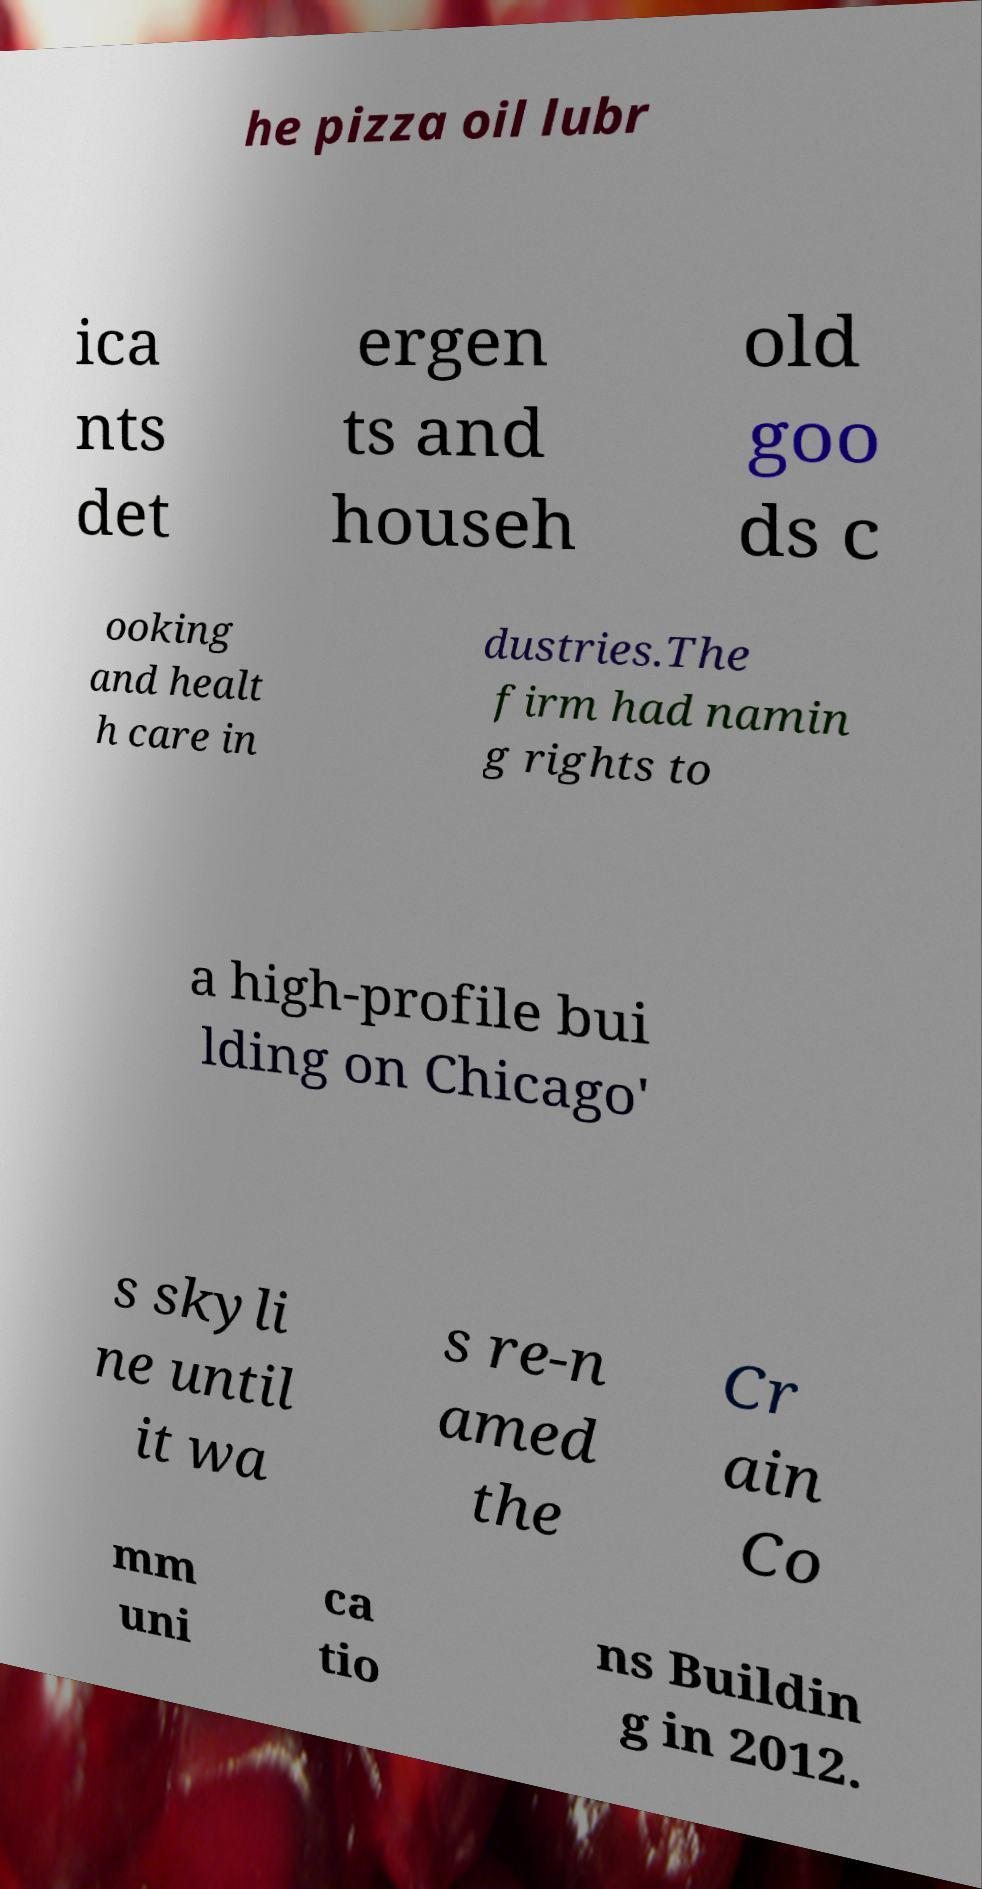There's text embedded in this image that I need extracted. Can you transcribe it verbatim? he pizza oil lubr ica nts det ergen ts and househ old goo ds c ooking and healt h care in dustries.The firm had namin g rights to a high-profile bui lding on Chicago' s skyli ne until it wa s re-n amed the Cr ain Co mm uni ca tio ns Buildin g in 2012. 